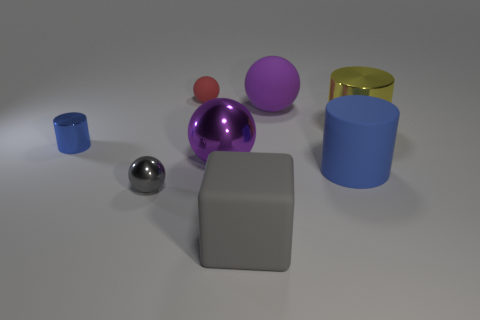Does the small cylinder have the same color as the tiny rubber sphere? no 